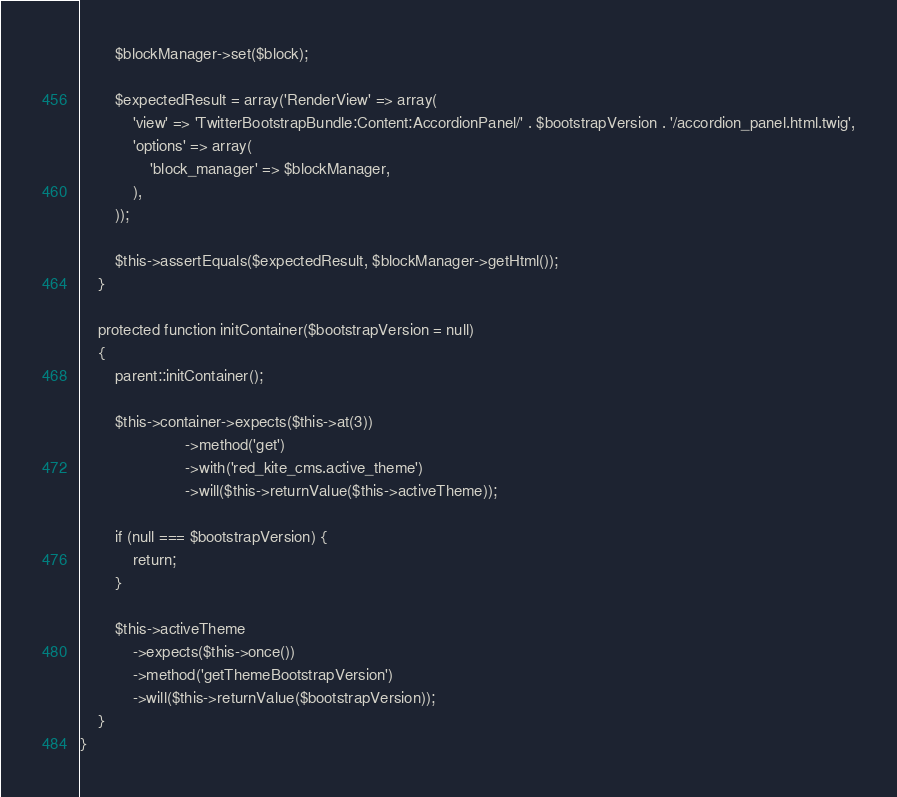Convert code to text. <code><loc_0><loc_0><loc_500><loc_500><_PHP_>        $blockManager->set($block);
        
        $expectedResult = array('RenderView' => array(
            'view' => 'TwitterBootstrapBundle:Content:AccordionPanel/' . $bootstrapVersion . '/accordion_panel.html.twig',
            'options' => array(
                'block_manager' => $blockManager,
            ),
        ));
        
        $this->assertEquals($expectedResult, $blockManager->getHtml());
    }
    
    protected function initContainer($bootstrapVersion = null)
    {
        parent::initContainer();
        
        $this->container->expects($this->at(3))
                        ->method('get')
                        ->with('red_kite_cms.active_theme')
                        ->will($this->returnValue($this->activeTheme));
        
        if (null === $bootstrapVersion) {
            return;
        }
        
        $this->activeTheme
            ->expects($this->once())
            ->method('getThemeBootstrapVersion')
            ->will($this->returnValue($bootstrapVersion));
    }
}
</code> 